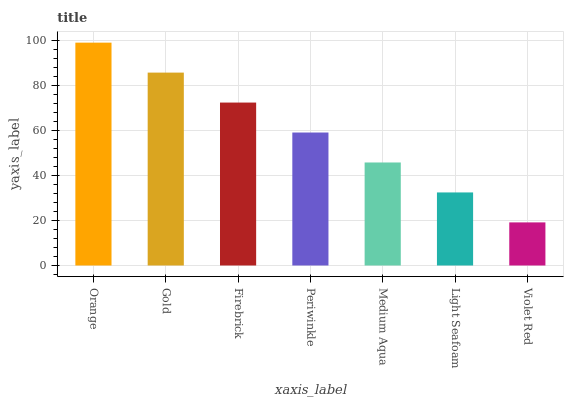Is Gold the minimum?
Answer yes or no. No. Is Gold the maximum?
Answer yes or no. No. Is Orange greater than Gold?
Answer yes or no. Yes. Is Gold less than Orange?
Answer yes or no. Yes. Is Gold greater than Orange?
Answer yes or no. No. Is Orange less than Gold?
Answer yes or no. No. Is Periwinkle the high median?
Answer yes or no. Yes. Is Periwinkle the low median?
Answer yes or no. Yes. Is Firebrick the high median?
Answer yes or no. No. Is Violet Red the low median?
Answer yes or no. No. 